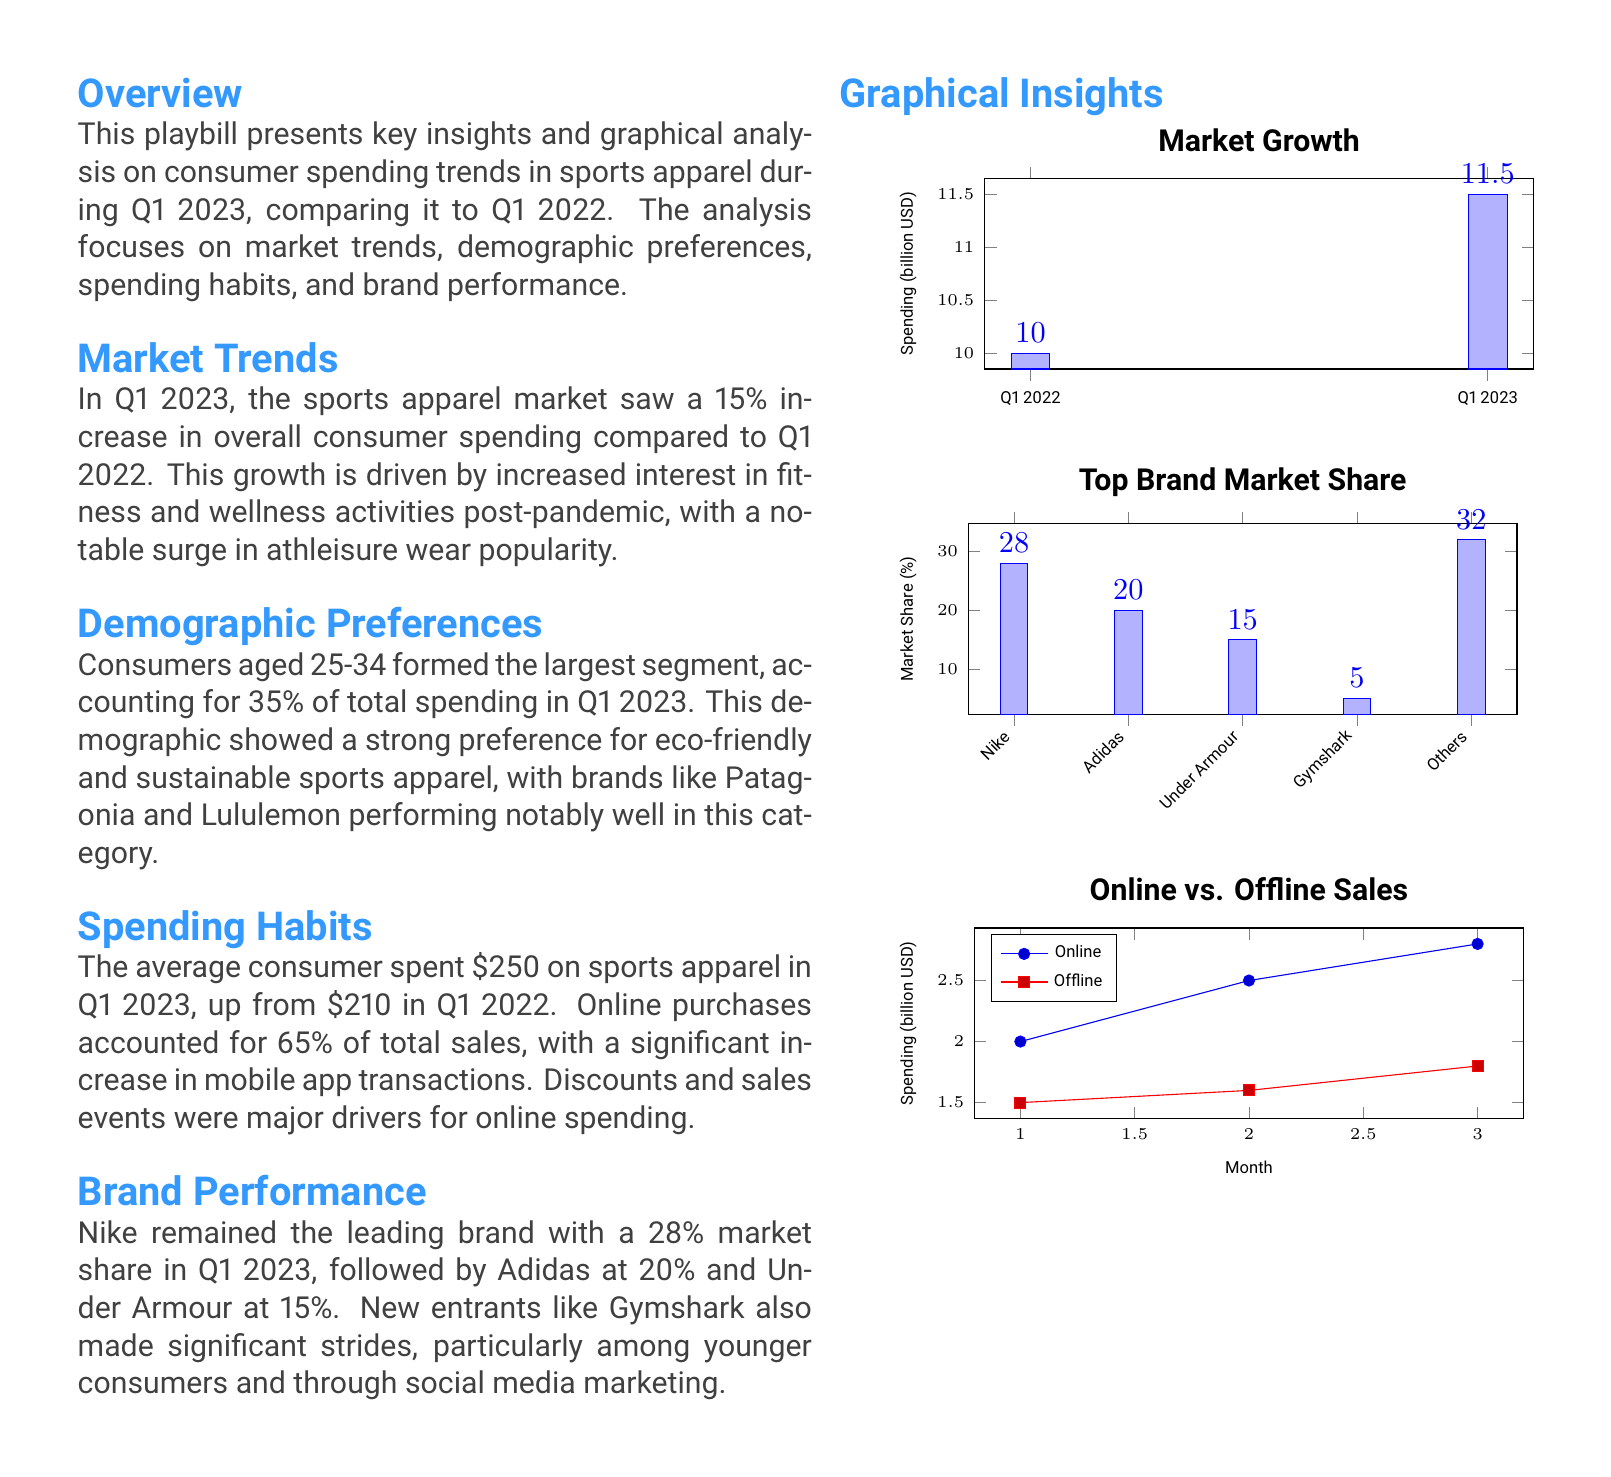what was the increase in consumer spending compared to Q1 2022? The document states that there was a 15% increase in overall consumer spending in Q1 2023 compared to Q1 2022.
Answer: 15% which age group accounts for the largest segment of spending? The overview mentions that consumers aged 25-34 formed the largest segment, accounting for 35% of total spending in Q1 2023.
Answer: 25-34 what is the average consumer spending in Q1 2023? The playbill indicates that the average consumer spent $250 on sports apparel in Q1 2023.
Answer: $250 which brand holds the highest market share in Q1 2023? According to the document, Nike remained the leading brand with a 28% market share in Q1 2023.
Answer: Nike what percentage of total sales came from online purchases? The spending habits section states that online purchases accounted for 65% of total sales in Q1 2023.
Answer: 65% how much did the market grow from Q1 2022 to Q1 2023 in billion USD? The graphical insight about market growth lists Q1 2022 spending as 10 billion USD and Q1 2023 as 11.5 billion USD, showing a growth of 1.5 billion USD.
Answer: 1.5 billion who are the notable performers in the eco-friendly apparel segment? The demographic preferences section highlights Patagonia and Lululemon as notable performers in eco-friendly and sustainable sports apparel.
Answer: Patagonia and Lululemon which is identified as a significant driver for online spending? The spending habits section mentions that discounts and sales events were major drivers for online spending.
Answer: Discounts and sales events what type of document is this? This document presents an analysis of consumer spending trends specific to sports apparel for Q1 2023 and includes graphical insights.
Answer: Playbill 